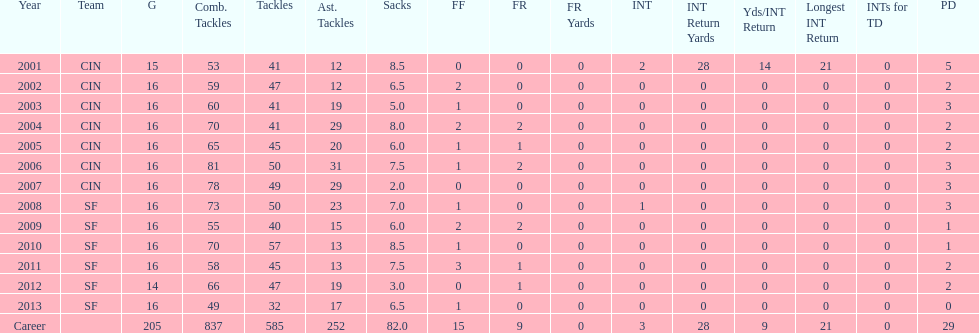How many seasons had combined tackles of 70 or more? 5. 